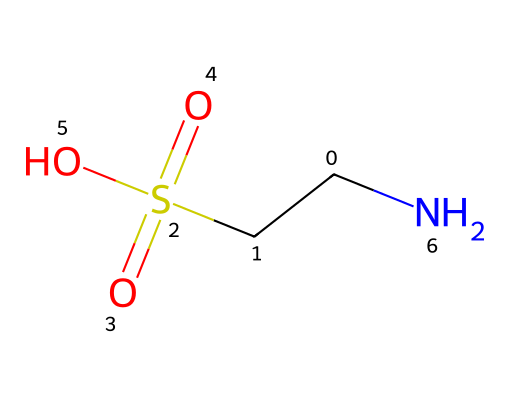What is the total number of carbon atoms in this molecule? By examining the SMILES representation (C(CS(=O)(=O)O)N), we see one 'C' indicates a carbon atom at the start and another 'C' in the parentheses indicates there's an additional carbon connected to a sulfur. Therefore, there are two carbon atoms.
Answer: two How many total sulfur atoms are present in the chemical structure? In the SMILES representation, we see the 'S' used once, which indicates that there is one sulfur atom in the structure of this compound.
Answer: one What is the primary functional group present in this molecule? The structure shows the presence of the -SO3H (sulfonic acid) group indicated by 'S(=O)(=O)O', which is the primary functional group in this molecule.
Answer: sulfonic acid How many nitrogen atoms are present in the molecule? In the SMILES representation, we can see the 'N' included, indicating there is one nitrogen atom in this compound.
Answer: one Is taurine a carboxylic acid? Although taurine has a -SO3H group, it does not contain a -COOH group which is characteristic of carboxylic acids. Thus, it does not fit the definition of a carboxylic acid.
Answer: no What kind of interactions might the sulfonic acid group in taurine facilitate? The presence of the sulfonic acid group suggests strong hydrogen bonding and potential interaction with water due to its polarity, enabling taurine to be soluble in water.
Answer: hydrogen bonding 